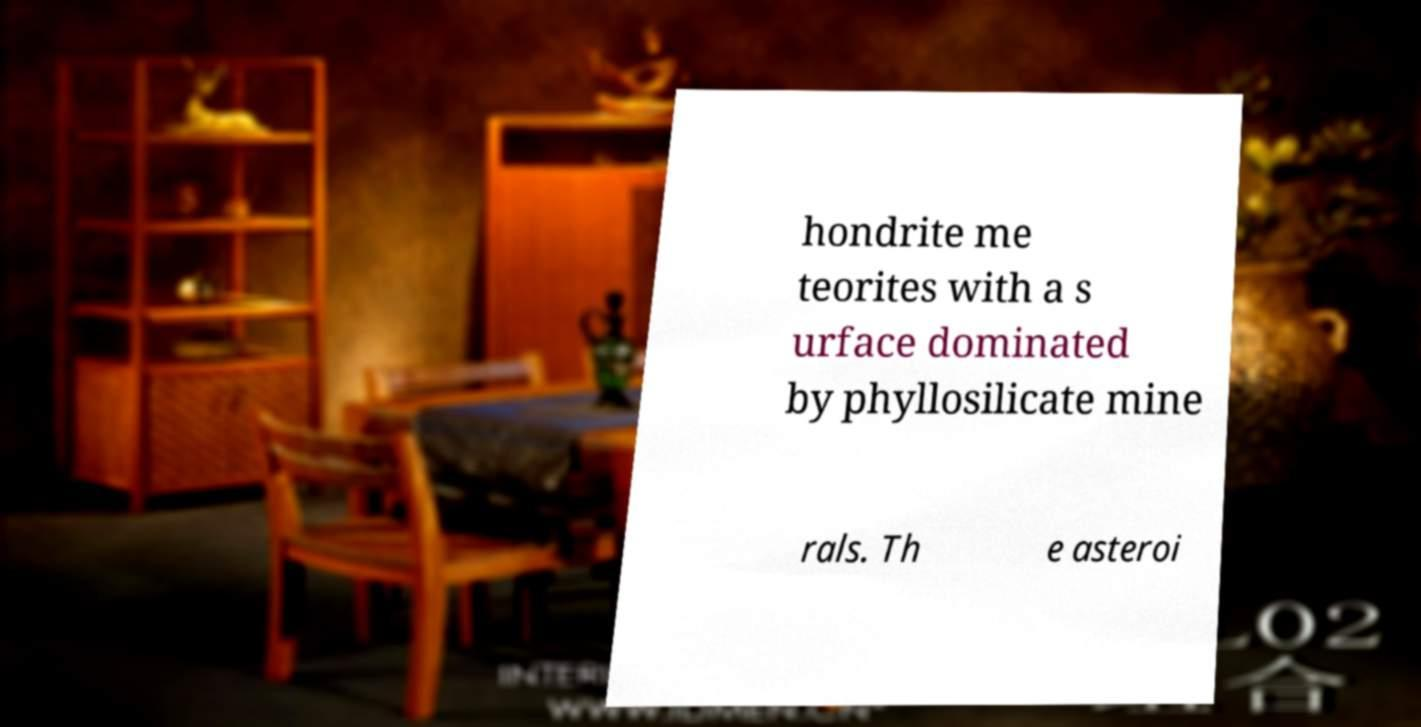For documentation purposes, I need the text within this image transcribed. Could you provide that? hondrite me teorites with a s urface dominated by phyllosilicate mine rals. Th e asteroi 